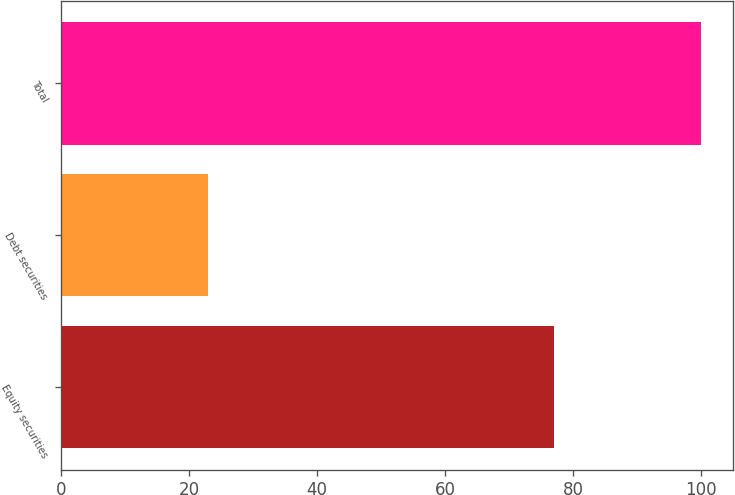Convert chart to OTSL. <chart><loc_0><loc_0><loc_500><loc_500><bar_chart><fcel>Equity securities<fcel>Debt securities<fcel>Total<nl><fcel>77<fcel>23<fcel>100<nl></chart> 